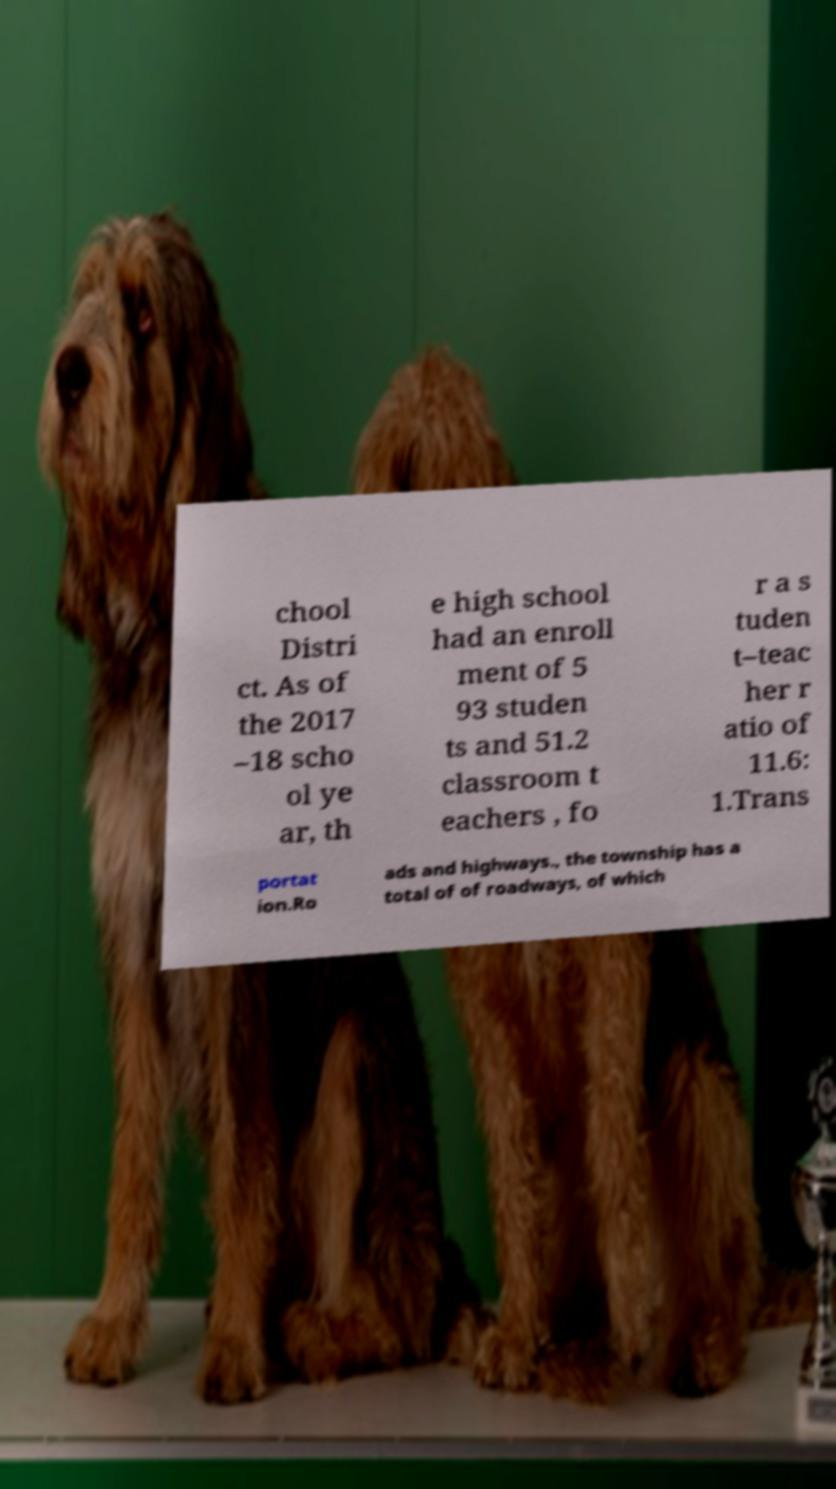Please identify and transcribe the text found in this image. chool Distri ct. As of the 2017 –18 scho ol ye ar, th e high school had an enroll ment of 5 93 studen ts and 51.2 classroom t eachers , fo r a s tuden t–teac her r atio of 11.6: 1.Trans portat ion.Ro ads and highways., the township has a total of of roadways, of which 